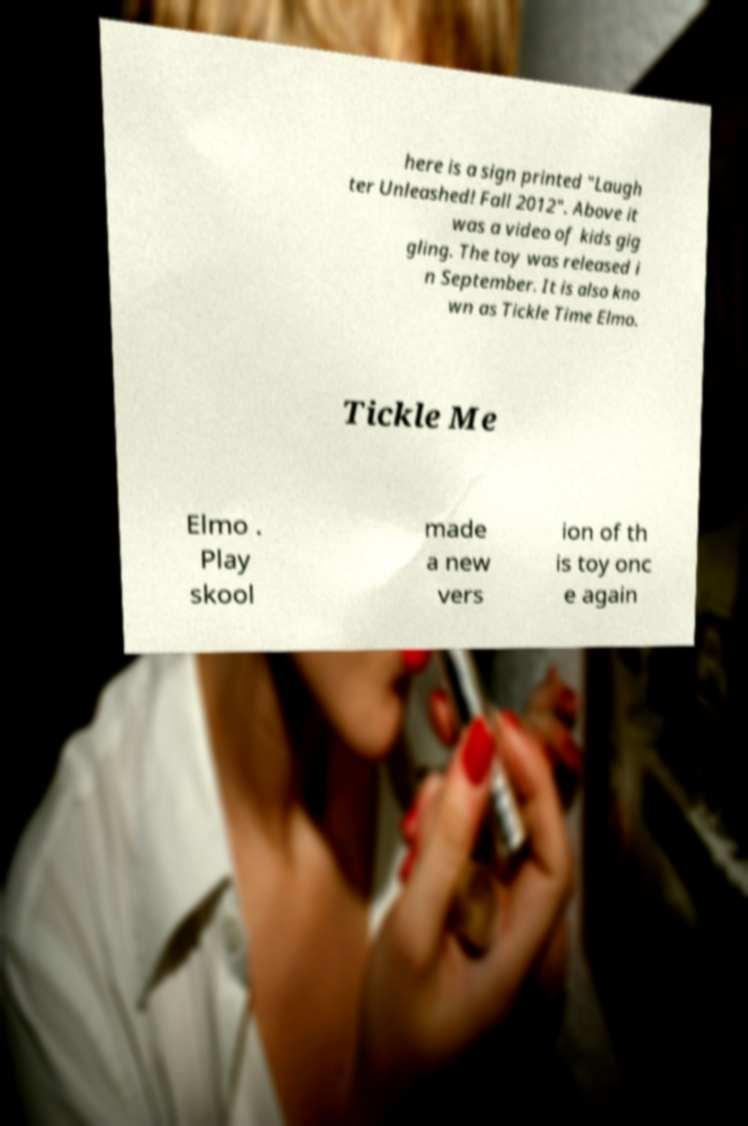Please read and relay the text visible in this image. What does it say? here is a sign printed "Laugh ter Unleashed! Fall 2012". Above it was a video of kids gig gling. The toy was released i n September. It is also kno wn as Tickle Time Elmo. Tickle Me Elmo . Play skool made a new vers ion of th is toy onc e again 